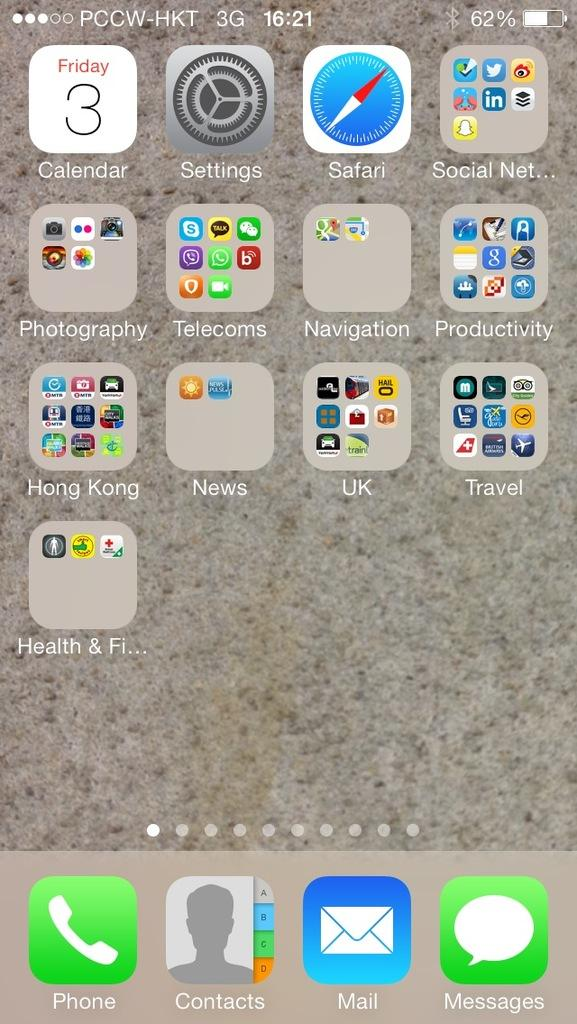<image>
Summarize the visual content of the image. A screenshot of a phone interface with 3G signal. 